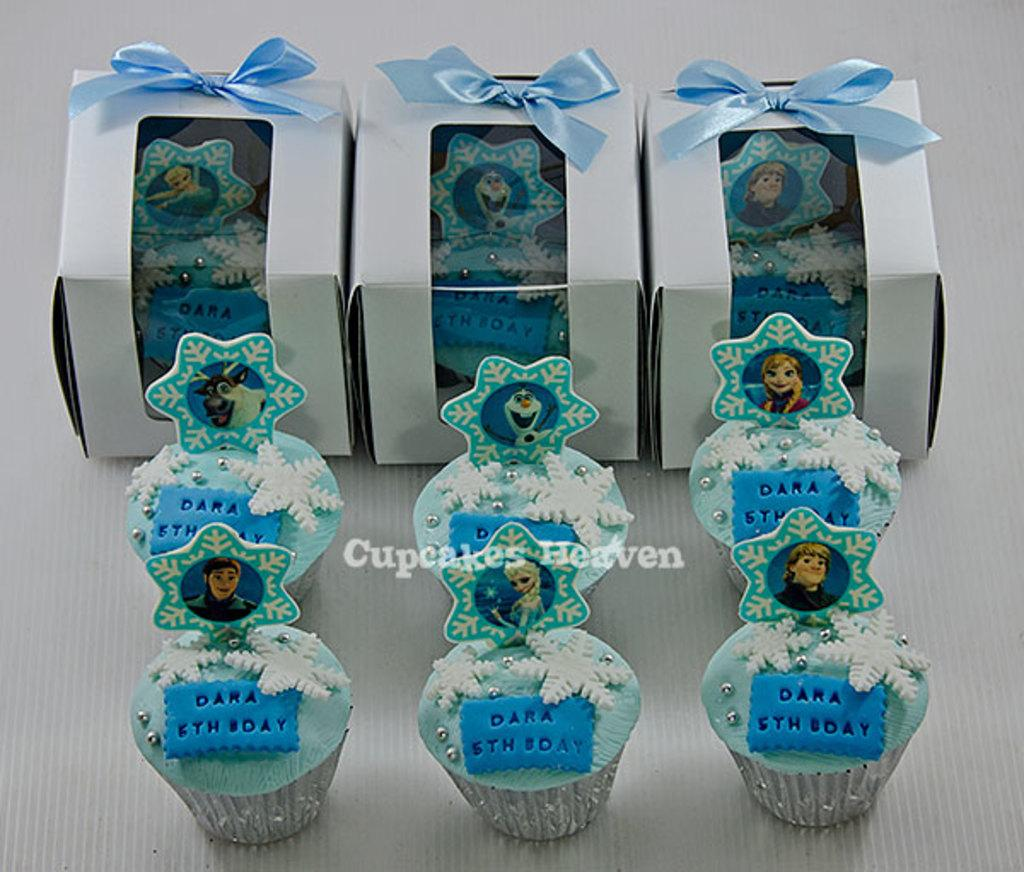What type of food can be seen in the image? The image contains cupcakes. What are the boxes in the image used for? The boxes in the image contain cupcakes. What color are the cupcakes? The cupcakes are in blue color. What type of skirt is worn by the cupcakes in the image? There are no skirts present in the image, as the subject is cupcakes, which are food items and not people. 